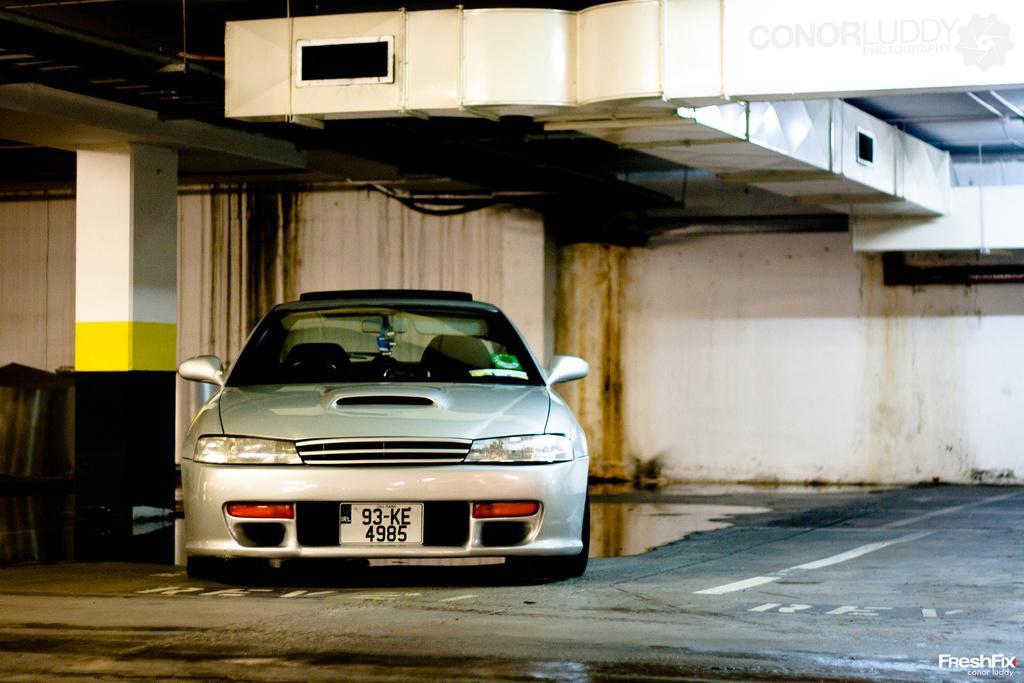Can you describe this image briefly? In the image we can see the vehicle and these are the headlights and number plate of the vehicle. Here we can see the floor, pillar and it looks like a building. On the bottom right and top right, we can see the watermark. 